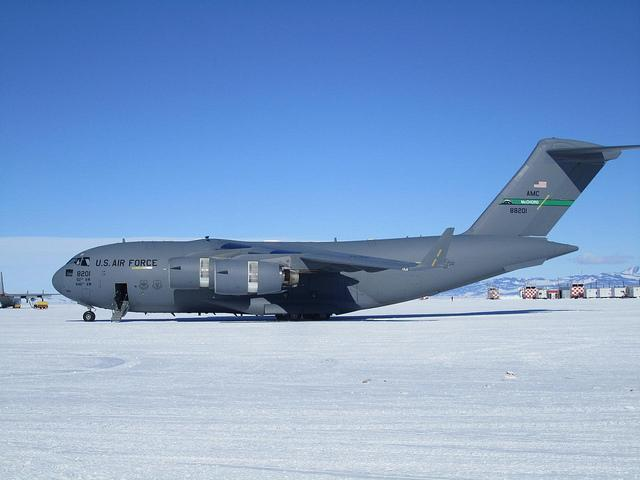The plane is most likely dropping off what to the people? supplies 